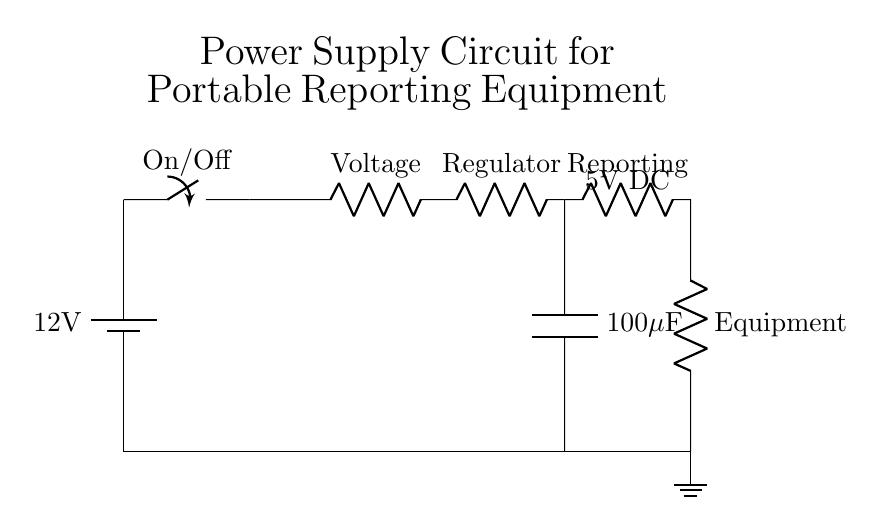What is the voltage of the power supply? The circuit shows a battery labeled as providing 12 volts, which indicates the input voltage for the circuit.
Answer: 12 volts What type of switch is used in the circuit? The circuit includes an On/Off switch, which allows the user to control the power supply to the rest of the circuit by either connecting or disconnecting the battery from the load.
Answer: On/Off What is the purpose of the voltage regulator? The voltage regulator is designed to stabilize the output voltage for the connected equipment, ensuring that it operates properly under various conditions, and in this case, it regulates to 5 volts.
Answer: Stabilizing voltage Which component is responsible for filtering the output? The output capacitor labeled as 100 microfarads serves to filter the output voltage by smoothing out voltage fluctuations that might occur when the load changes, which helps maintain a steady voltage supply.
Answer: Capacitor What is the output voltage supplied to the reporting equipment? The output voltage is directly indicated in the diagram above the output load, showing that the reporting equipment receives 5 volts DC from the voltage regulator.
Answer: 5 volts DC What would happen if the voltage regulator fails? If the voltage regulator fails, the output voltage could become unstable or exceed the required 5 volts DC, which may damage the reporting equipment connected to the circuit.
Answer: Equipment damage What is the total load indicated in the circuit? The circuit diagram shows the reporting equipment as the load, which consists of two components labeled as Reporting and Equipment, indicating that these are the actual components drawing power from the circuit.
Answer: Reporting equipment 